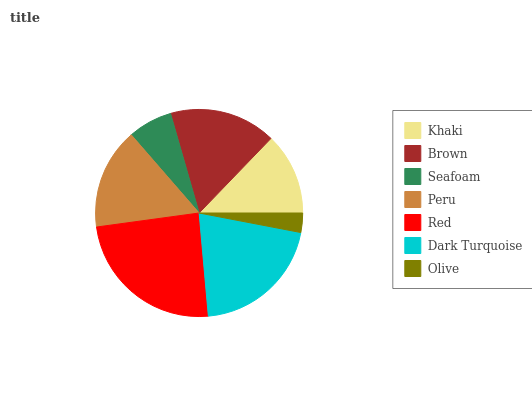Is Olive the minimum?
Answer yes or no. Yes. Is Red the maximum?
Answer yes or no. Yes. Is Brown the minimum?
Answer yes or no. No. Is Brown the maximum?
Answer yes or no. No. Is Brown greater than Khaki?
Answer yes or no. Yes. Is Khaki less than Brown?
Answer yes or no. Yes. Is Khaki greater than Brown?
Answer yes or no. No. Is Brown less than Khaki?
Answer yes or no. No. Is Peru the high median?
Answer yes or no. Yes. Is Peru the low median?
Answer yes or no. Yes. Is Red the high median?
Answer yes or no. No. Is Dark Turquoise the low median?
Answer yes or no. No. 